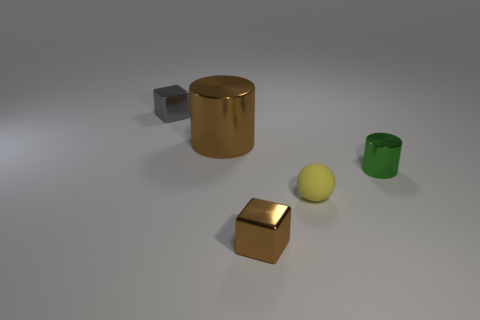Add 1 brown things. How many objects exist? 6 Subtract all cylinders. How many objects are left? 3 Subtract all yellow things. Subtract all small green metal spheres. How many objects are left? 4 Add 5 tiny cylinders. How many tiny cylinders are left? 6 Add 3 tiny blocks. How many tiny blocks exist? 5 Subtract 0 green spheres. How many objects are left? 5 